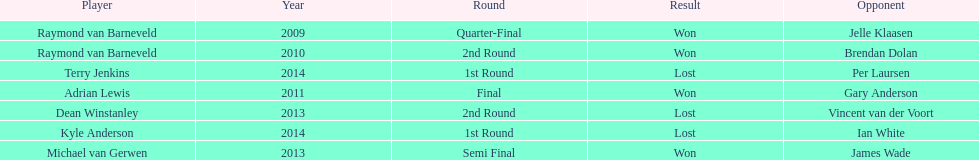Parse the full table. {'header': ['Player', 'Year', 'Round', 'Result', 'Opponent'], 'rows': [['Raymond van Barneveld', '2009', 'Quarter-Final', 'Won', 'Jelle Klaasen'], ['Raymond van Barneveld', '2010', '2nd Round', 'Won', 'Brendan Dolan'], ['Terry Jenkins', '2014', '1st Round', 'Lost', 'Per Laursen'], ['Adrian Lewis', '2011', 'Final', 'Won', 'Gary Anderson'], ['Dean Winstanley', '2013', '2nd Round', 'Lost', 'Vincent van der Voort'], ['Kyle Anderson', '2014', '1st Round', 'Lost', 'Ian White'], ['Michael van Gerwen', '2013', 'Semi Final', 'Won', 'James Wade']]} Other than kyle anderson, who else lost in 2014? Terry Jenkins. 